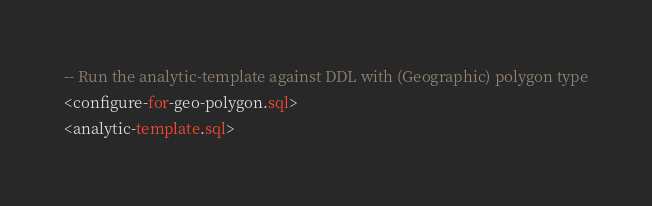Convert code to text. <code><loc_0><loc_0><loc_500><loc_500><_SQL_>-- Run the analytic-template against DDL with (Geographic) polygon type
<configure-for-geo-polygon.sql>
<analytic-template.sql>
</code> 